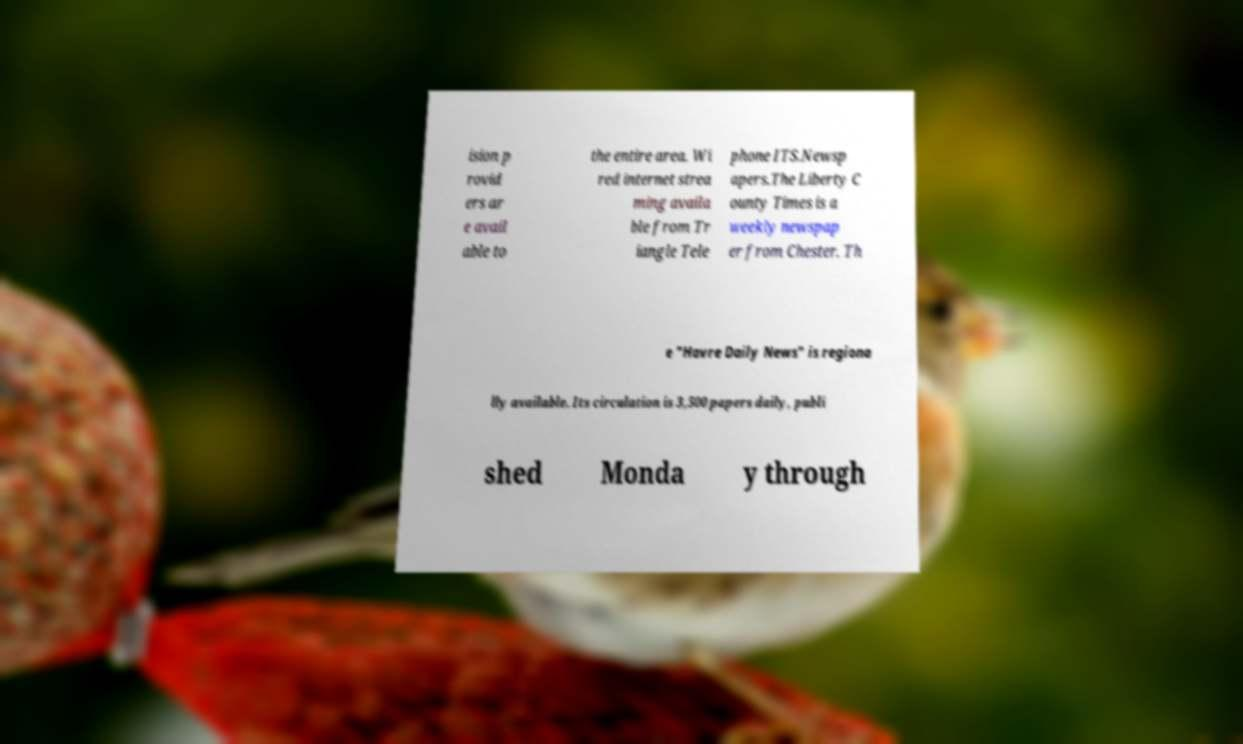Please identify and transcribe the text found in this image. ision p rovid ers ar e avail able to the entire area. Wi red internet strea ming availa ble from Tr iangle Tele phone ITS.Newsp apers.The Liberty C ounty Times is a weekly newspap er from Chester. Th e "Havre Daily News" is regiona lly available. Its circulation is 3,500 papers daily, publi shed Monda y through 